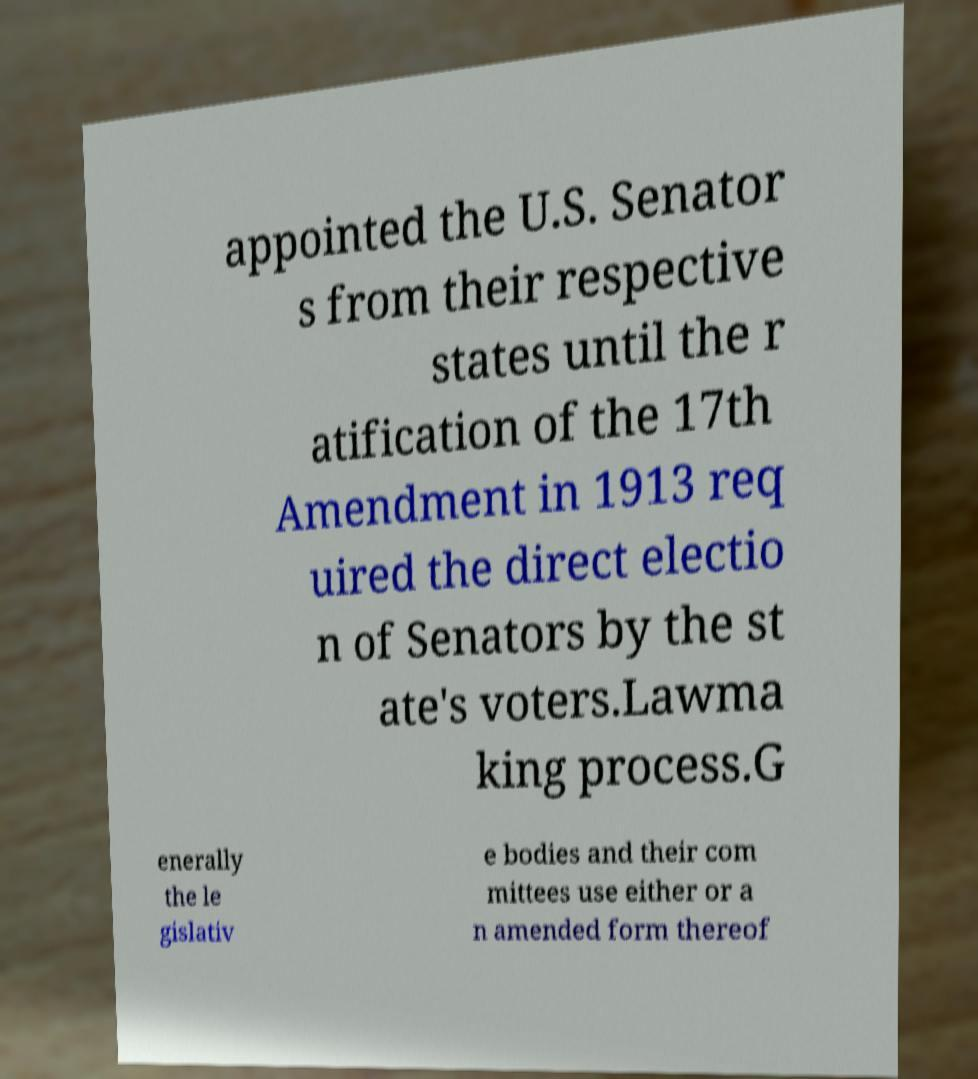Can you accurately transcribe the text from the provided image for me? appointed the U.S. Senator s from their respective states until the r atification of the 17th Amendment in 1913 req uired the direct electio n of Senators by the st ate's voters.Lawma king process.G enerally the le gislativ e bodies and their com mittees use either or a n amended form thereof 